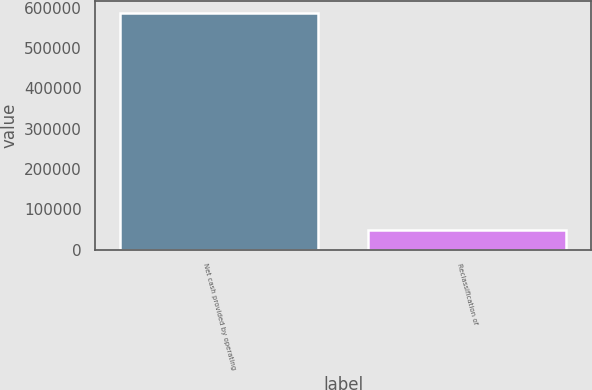Convert chart to OTSL. <chart><loc_0><loc_0><loc_500><loc_500><bar_chart><fcel>Net cash provided by operating<fcel>Reclassification of<nl><fcel>586340<fcel>48029<nl></chart> 